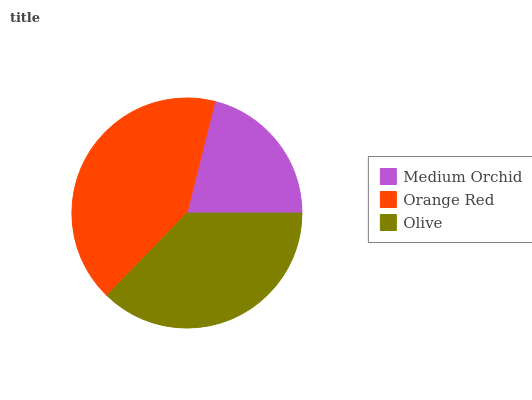Is Medium Orchid the minimum?
Answer yes or no. Yes. Is Orange Red the maximum?
Answer yes or no. Yes. Is Olive the minimum?
Answer yes or no. No. Is Olive the maximum?
Answer yes or no. No. Is Orange Red greater than Olive?
Answer yes or no. Yes. Is Olive less than Orange Red?
Answer yes or no. Yes. Is Olive greater than Orange Red?
Answer yes or no. No. Is Orange Red less than Olive?
Answer yes or no. No. Is Olive the high median?
Answer yes or no. Yes. Is Olive the low median?
Answer yes or no. Yes. Is Medium Orchid the high median?
Answer yes or no. No. Is Orange Red the low median?
Answer yes or no. No. 